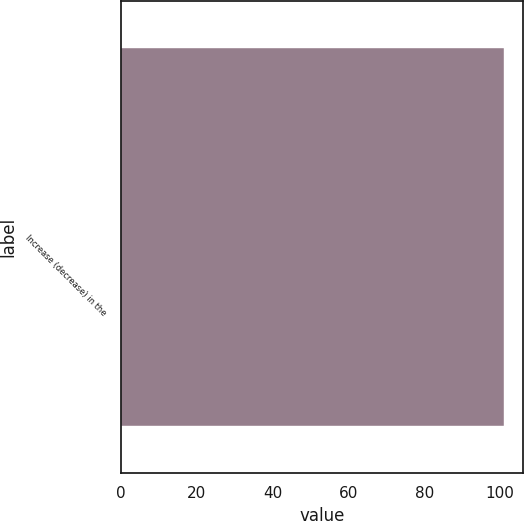Convert chart to OTSL. <chart><loc_0><loc_0><loc_500><loc_500><bar_chart><fcel>Increase (decrease) in the<nl><fcel>101<nl></chart> 